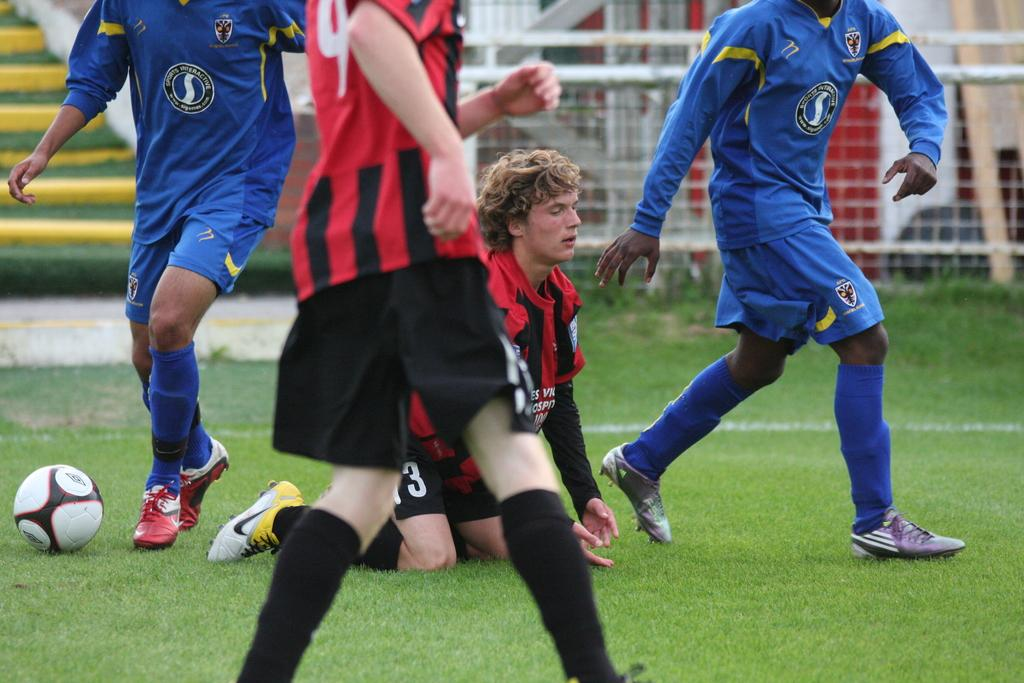What are the main subjects in the image? There are players and a ball in the image. What is the surface on which the players and ball are located? The players and ball are on the grass. What can be seen in the background of the image? There is fencing and stairs in the background of the image. What type of hook is used by the players to catch the ball in the image? There is no hook present in the image; the players are using their hands to play with the ball. 